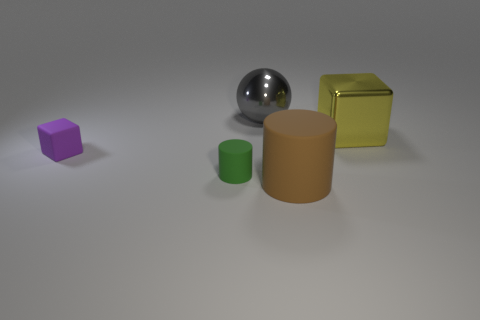Add 1 purple metallic cylinders. How many objects exist? 6 Subtract all blocks. How many objects are left? 3 Add 4 purple rubber objects. How many purple rubber objects are left? 5 Add 4 rubber balls. How many rubber balls exist? 4 Subtract 0 blue balls. How many objects are left? 5 Subtract all metal objects. Subtract all purple blocks. How many objects are left? 2 